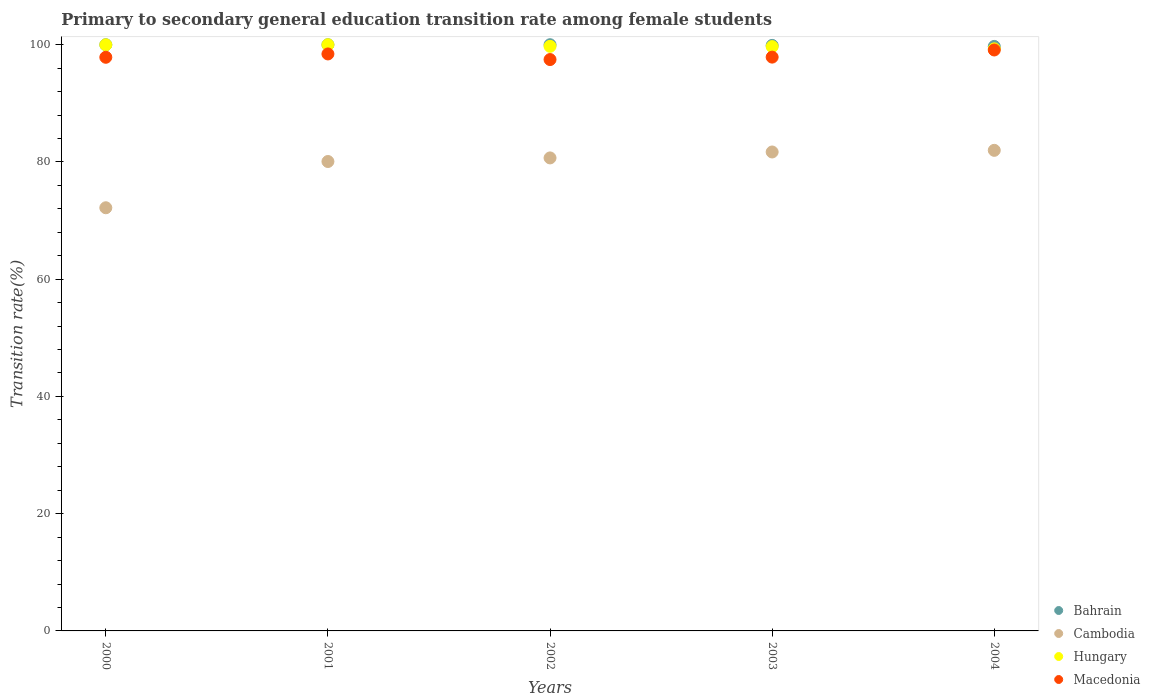What is the transition rate in Macedonia in 2002?
Your answer should be very brief. 97.47. Across all years, what is the maximum transition rate in Cambodia?
Offer a very short reply. 81.98. Across all years, what is the minimum transition rate in Hungary?
Give a very brief answer. 99.3. What is the total transition rate in Macedonia in the graph?
Your answer should be very brief. 490.74. What is the difference between the transition rate in Hungary in 2002 and that in 2003?
Make the answer very short. 0.05. What is the difference between the transition rate in Bahrain in 2003 and the transition rate in Cambodia in 2001?
Offer a terse response. 19.81. What is the average transition rate in Cambodia per year?
Your answer should be very brief. 79.33. In the year 2002, what is the difference between the transition rate in Cambodia and transition rate in Bahrain?
Your response must be concise. -19.31. In how many years, is the transition rate in Hungary greater than 20 %?
Make the answer very short. 5. What is the ratio of the transition rate in Hungary in 2000 to that in 2002?
Your response must be concise. 1. Is the transition rate in Hungary in 2000 less than that in 2003?
Keep it short and to the point. No. Is the difference between the transition rate in Cambodia in 2000 and 2001 greater than the difference between the transition rate in Bahrain in 2000 and 2001?
Provide a short and direct response. No. What is the difference between the highest and the second highest transition rate in Macedonia?
Give a very brief answer. 0.67. What is the difference between the highest and the lowest transition rate in Cambodia?
Provide a short and direct response. 9.8. Is it the case that in every year, the sum of the transition rate in Cambodia and transition rate in Macedonia  is greater than the transition rate in Bahrain?
Offer a terse response. Yes. Does the transition rate in Macedonia monotonically increase over the years?
Keep it short and to the point. No. Is the transition rate in Bahrain strictly greater than the transition rate in Hungary over the years?
Provide a succinct answer. No. Is the transition rate in Hungary strictly less than the transition rate in Macedonia over the years?
Your response must be concise. No. How many dotlines are there?
Ensure brevity in your answer.  4. What is the difference between two consecutive major ticks on the Y-axis?
Offer a terse response. 20. Does the graph contain any zero values?
Ensure brevity in your answer.  No. Does the graph contain grids?
Ensure brevity in your answer.  No. Where does the legend appear in the graph?
Offer a very short reply. Bottom right. What is the title of the graph?
Offer a very short reply. Primary to secondary general education transition rate among female students. What is the label or title of the Y-axis?
Ensure brevity in your answer.  Transition rate(%). What is the Transition rate(%) of Bahrain in 2000?
Make the answer very short. 100. What is the Transition rate(%) in Cambodia in 2000?
Keep it short and to the point. 72.19. What is the Transition rate(%) in Hungary in 2000?
Provide a succinct answer. 99.98. What is the Transition rate(%) of Macedonia in 2000?
Your answer should be very brief. 97.86. What is the Transition rate(%) in Bahrain in 2001?
Provide a short and direct response. 100. What is the Transition rate(%) in Cambodia in 2001?
Ensure brevity in your answer.  80.08. What is the Transition rate(%) in Macedonia in 2001?
Ensure brevity in your answer.  98.43. What is the Transition rate(%) of Bahrain in 2002?
Offer a very short reply. 100. What is the Transition rate(%) in Cambodia in 2002?
Give a very brief answer. 80.69. What is the Transition rate(%) in Hungary in 2002?
Ensure brevity in your answer.  99.73. What is the Transition rate(%) of Macedonia in 2002?
Keep it short and to the point. 97.47. What is the Transition rate(%) in Bahrain in 2003?
Your response must be concise. 99.89. What is the Transition rate(%) of Cambodia in 2003?
Give a very brief answer. 81.7. What is the Transition rate(%) of Hungary in 2003?
Provide a short and direct response. 99.68. What is the Transition rate(%) in Macedonia in 2003?
Your answer should be very brief. 97.88. What is the Transition rate(%) in Bahrain in 2004?
Keep it short and to the point. 99.71. What is the Transition rate(%) in Cambodia in 2004?
Your answer should be compact. 81.98. What is the Transition rate(%) of Hungary in 2004?
Provide a succinct answer. 99.3. What is the Transition rate(%) in Macedonia in 2004?
Ensure brevity in your answer.  99.1. Across all years, what is the maximum Transition rate(%) in Bahrain?
Give a very brief answer. 100. Across all years, what is the maximum Transition rate(%) of Cambodia?
Make the answer very short. 81.98. Across all years, what is the maximum Transition rate(%) of Hungary?
Your answer should be compact. 100. Across all years, what is the maximum Transition rate(%) in Macedonia?
Give a very brief answer. 99.1. Across all years, what is the minimum Transition rate(%) of Bahrain?
Your answer should be compact. 99.71. Across all years, what is the minimum Transition rate(%) of Cambodia?
Provide a short and direct response. 72.19. Across all years, what is the minimum Transition rate(%) in Hungary?
Give a very brief answer. 99.3. Across all years, what is the minimum Transition rate(%) of Macedonia?
Offer a terse response. 97.47. What is the total Transition rate(%) of Bahrain in the graph?
Offer a very short reply. 499.6. What is the total Transition rate(%) in Cambodia in the graph?
Offer a terse response. 396.64. What is the total Transition rate(%) in Hungary in the graph?
Give a very brief answer. 498.69. What is the total Transition rate(%) of Macedonia in the graph?
Your answer should be compact. 490.74. What is the difference between the Transition rate(%) in Bahrain in 2000 and that in 2001?
Your answer should be very brief. 0. What is the difference between the Transition rate(%) in Cambodia in 2000 and that in 2001?
Make the answer very short. -7.89. What is the difference between the Transition rate(%) in Hungary in 2000 and that in 2001?
Offer a terse response. -0.02. What is the difference between the Transition rate(%) in Macedonia in 2000 and that in 2001?
Your answer should be compact. -0.57. What is the difference between the Transition rate(%) in Bahrain in 2000 and that in 2002?
Ensure brevity in your answer.  0. What is the difference between the Transition rate(%) of Cambodia in 2000 and that in 2002?
Give a very brief answer. -8.5. What is the difference between the Transition rate(%) of Hungary in 2000 and that in 2002?
Your answer should be compact. 0.26. What is the difference between the Transition rate(%) in Macedonia in 2000 and that in 2002?
Offer a terse response. 0.39. What is the difference between the Transition rate(%) in Bahrain in 2000 and that in 2003?
Your answer should be compact. 0.11. What is the difference between the Transition rate(%) in Cambodia in 2000 and that in 2003?
Offer a terse response. -9.52. What is the difference between the Transition rate(%) in Hungary in 2000 and that in 2003?
Offer a terse response. 0.31. What is the difference between the Transition rate(%) of Macedonia in 2000 and that in 2003?
Offer a very short reply. -0.03. What is the difference between the Transition rate(%) in Bahrain in 2000 and that in 2004?
Provide a short and direct response. 0.29. What is the difference between the Transition rate(%) of Cambodia in 2000 and that in 2004?
Your answer should be very brief. -9.8. What is the difference between the Transition rate(%) in Hungary in 2000 and that in 2004?
Keep it short and to the point. 0.68. What is the difference between the Transition rate(%) of Macedonia in 2000 and that in 2004?
Offer a terse response. -1.24. What is the difference between the Transition rate(%) in Cambodia in 2001 and that in 2002?
Provide a short and direct response. -0.61. What is the difference between the Transition rate(%) of Hungary in 2001 and that in 2002?
Give a very brief answer. 0.27. What is the difference between the Transition rate(%) of Macedonia in 2001 and that in 2002?
Give a very brief answer. 0.96. What is the difference between the Transition rate(%) in Bahrain in 2001 and that in 2003?
Provide a short and direct response. 0.11. What is the difference between the Transition rate(%) of Cambodia in 2001 and that in 2003?
Keep it short and to the point. -1.63. What is the difference between the Transition rate(%) in Hungary in 2001 and that in 2003?
Your response must be concise. 0.32. What is the difference between the Transition rate(%) of Macedonia in 2001 and that in 2003?
Offer a terse response. 0.54. What is the difference between the Transition rate(%) in Bahrain in 2001 and that in 2004?
Your answer should be very brief. 0.29. What is the difference between the Transition rate(%) in Cambodia in 2001 and that in 2004?
Offer a very short reply. -1.91. What is the difference between the Transition rate(%) of Hungary in 2001 and that in 2004?
Your answer should be compact. 0.7. What is the difference between the Transition rate(%) in Macedonia in 2001 and that in 2004?
Your answer should be compact. -0.67. What is the difference between the Transition rate(%) in Bahrain in 2002 and that in 2003?
Your answer should be compact. 0.11. What is the difference between the Transition rate(%) in Cambodia in 2002 and that in 2003?
Your answer should be compact. -1.01. What is the difference between the Transition rate(%) in Hungary in 2002 and that in 2003?
Your answer should be very brief. 0.05. What is the difference between the Transition rate(%) of Macedonia in 2002 and that in 2003?
Provide a succinct answer. -0.41. What is the difference between the Transition rate(%) in Bahrain in 2002 and that in 2004?
Offer a very short reply. 0.29. What is the difference between the Transition rate(%) of Cambodia in 2002 and that in 2004?
Give a very brief answer. -1.29. What is the difference between the Transition rate(%) in Hungary in 2002 and that in 2004?
Your answer should be very brief. 0.42. What is the difference between the Transition rate(%) in Macedonia in 2002 and that in 2004?
Give a very brief answer. -1.63. What is the difference between the Transition rate(%) in Bahrain in 2003 and that in 2004?
Your answer should be very brief. 0.18. What is the difference between the Transition rate(%) in Cambodia in 2003 and that in 2004?
Your answer should be compact. -0.28. What is the difference between the Transition rate(%) in Hungary in 2003 and that in 2004?
Keep it short and to the point. 0.38. What is the difference between the Transition rate(%) of Macedonia in 2003 and that in 2004?
Your response must be concise. -1.22. What is the difference between the Transition rate(%) in Bahrain in 2000 and the Transition rate(%) in Cambodia in 2001?
Your answer should be compact. 19.92. What is the difference between the Transition rate(%) in Bahrain in 2000 and the Transition rate(%) in Hungary in 2001?
Make the answer very short. 0. What is the difference between the Transition rate(%) in Bahrain in 2000 and the Transition rate(%) in Macedonia in 2001?
Offer a very short reply. 1.57. What is the difference between the Transition rate(%) of Cambodia in 2000 and the Transition rate(%) of Hungary in 2001?
Make the answer very short. -27.81. What is the difference between the Transition rate(%) of Cambodia in 2000 and the Transition rate(%) of Macedonia in 2001?
Offer a very short reply. -26.24. What is the difference between the Transition rate(%) of Hungary in 2000 and the Transition rate(%) of Macedonia in 2001?
Provide a short and direct response. 1.56. What is the difference between the Transition rate(%) of Bahrain in 2000 and the Transition rate(%) of Cambodia in 2002?
Provide a short and direct response. 19.31. What is the difference between the Transition rate(%) of Bahrain in 2000 and the Transition rate(%) of Hungary in 2002?
Make the answer very short. 0.27. What is the difference between the Transition rate(%) in Bahrain in 2000 and the Transition rate(%) in Macedonia in 2002?
Provide a short and direct response. 2.53. What is the difference between the Transition rate(%) in Cambodia in 2000 and the Transition rate(%) in Hungary in 2002?
Give a very brief answer. -27.54. What is the difference between the Transition rate(%) in Cambodia in 2000 and the Transition rate(%) in Macedonia in 2002?
Make the answer very short. -25.28. What is the difference between the Transition rate(%) in Hungary in 2000 and the Transition rate(%) in Macedonia in 2002?
Ensure brevity in your answer.  2.51. What is the difference between the Transition rate(%) of Bahrain in 2000 and the Transition rate(%) of Cambodia in 2003?
Offer a terse response. 18.3. What is the difference between the Transition rate(%) of Bahrain in 2000 and the Transition rate(%) of Hungary in 2003?
Give a very brief answer. 0.32. What is the difference between the Transition rate(%) in Bahrain in 2000 and the Transition rate(%) in Macedonia in 2003?
Ensure brevity in your answer.  2.12. What is the difference between the Transition rate(%) of Cambodia in 2000 and the Transition rate(%) of Hungary in 2003?
Your response must be concise. -27.49. What is the difference between the Transition rate(%) in Cambodia in 2000 and the Transition rate(%) in Macedonia in 2003?
Ensure brevity in your answer.  -25.7. What is the difference between the Transition rate(%) in Hungary in 2000 and the Transition rate(%) in Macedonia in 2003?
Provide a short and direct response. 2.1. What is the difference between the Transition rate(%) of Bahrain in 2000 and the Transition rate(%) of Cambodia in 2004?
Provide a short and direct response. 18.02. What is the difference between the Transition rate(%) in Bahrain in 2000 and the Transition rate(%) in Hungary in 2004?
Your response must be concise. 0.7. What is the difference between the Transition rate(%) of Bahrain in 2000 and the Transition rate(%) of Macedonia in 2004?
Give a very brief answer. 0.9. What is the difference between the Transition rate(%) of Cambodia in 2000 and the Transition rate(%) of Hungary in 2004?
Give a very brief answer. -27.11. What is the difference between the Transition rate(%) in Cambodia in 2000 and the Transition rate(%) in Macedonia in 2004?
Your answer should be compact. -26.92. What is the difference between the Transition rate(%) in Hungary in 2000 and the Transition rate(%) in Macedonia in 2004?
Offer a terse response. 0.88. What is the difference between the Transition rate(%) of Bahrain in 2001 and the Transition rate(%) of Cambodia in 2002?
Ensure brevity in your answer.  19.31. What is the difference between the Transition rate(%) of Bahrain in 2001 and the Transition rate(%) of Hungary in 2002?
Your answer should be very brief. 0.27. What is the difference between the Transition rate(%) in Bahrain in 2001 and the Transition rate(%) in Macedonia in 2002?
Your answer should be very brief. 2.53. What is the difference between the Transition rate(%) of Cambodia in 2001 and the Transition rate(%) of Hungary in 2002?
Make the answer very short. -19.65. What is the difference between the Transition rate(%) in Cambodia in 2001 and the Transition rate(%) in Macedonia in 2002?
Make the answer very short. -17.39. What is the difference between the Transition rate(%) in Hungary in 2001 and the Transition rate(%) in Macedonia in 2002?
Provide a succinct answer. 2.53. What is the difference between the Transition rate(%) in Bahrain in 2001 and the Transition rate(%) in Cambodia in 2003?
Ensure brevity in your answer.  18.3. What is the difference between the Transition rate(%) of Bahrain in 2001 and the Transition rate(%) of Hungary in 2003?
Provide a succinct answer. 0.32. What is the difference between the Transition rate(%) in Bahrain in 2001 and the Transition rate(%) in Macedonia in 2003?
Offer a terse response. 2.12. What is the difference between the Transition rate(%) in Cambodia in 2001 and the Transition rate(%) in Hungary in 2003?
Offer a terse response. -19.6. What is the difference between the Transition rate(%) in Cambodia in 2001 and the Transition rate(%) in Macedonia in 2003?
Your response must be concise. -17.81. What is the difference between the Transition rate(%) of Hungary in 2001 and the Transition rate(%) of Macedonia in 2003?
Your answer should be very brief. 2.12. What is the difference between the Transition rate(%) in Bahrain in 2001 and the Transition rate(%) in Cambodia in 2004?
Provide a short and direct response. 18.02. What is the difference between the Transition rate(%) in Bahrain in 2001 and the Transition rate(%) in Hungary in 2004?
Provide a short and direct response. 0.7. What is the difference between the Transition rate(%) of Bahrain in 2001 and the Transition rate(%) of Macedonia in 2004?
Give a very brief answer. 0.9. What is the difference between the Transition rate(%) in Cambodia in 2001 and the Transition rate(%) in Hungary in 2004?
Your answer should be very brief. -19.22. What is the difference between the Transition rate(%) of Cambodia in 2001 and the Transition rate(%) of Macedonia in 2004?
Provide a short and direct response. -19.02. What is the difference between the Transition rate(%) of Hungary in 2001 and the Transition rate(%) of Macedonia in 2004?
Provide a succinct answer. 0.9. What is the difference between the Transition rate(%) of Bahrain in 2002 and the Transition rate(%) of Cambodia in 2003?
Your answer should be very brief. 18.3. What is the difference between the Transition rate(%) in Bahrain in 2002 and the Transition rate(%) in Hungary in 2003?
Offer a very short reply. 0.32. What is the difference between the Transition rate(%) in Bahrain in 2002 and the Transition rate(%) in Macedonia in 2003?
Give a very brief answer. 2.12. What is the difference between the Transition rate(%) in Cambodia in 2002 and the Transition rate(%) in Hungary in 2003?
Your answer should be compact. -18.99. What is the difference between the Transition rate(%) of Cambodia in 2002 and the Transition rate(%) of Macedonia in 2003?
Your answer should be very brief. -17.19. What is the difference between the Transition rate(%) in Hungary in 2002 and the Transition rate(%) in Macedonia in 2003?
Ensure brevity in your answer.  1.84. What is the difference between the Transition rate(%) of Bahrain in 2002 and the Transition rate(%) of Cambodia in 2004?
Make the answer very short. 18.02. What is the difference between the Transition rate(%) of Bahrain in 2002 and the Transition rate(%) of Hungary in 2004?
Make the answer very short. 0.7. What is the difference between the Transition rate(%) of Bahrain in 2002 and the Transition rate(%) of Macedonia in 2004?
Offer a very short reply. 0.9. What is the difference between the Transition rate(%) of Cambodia in 2002 and the Transition rate(%) of Hungary in 2004?
Your answer should be compact. -18.61. What is the difference between the Transition rate(%) in Cambodia in 2002 and the Transition rate(%) in Macedonia in 2004?
Offer a terse response. -18.41. What is the difference between the Transition rate(%) in Hungary in 2002 and the Transition rate(%) in Macedonia in 2004?
Offer a very short reply. 0.62. What is the difference between the Transition rate(%) of Bahrain in 2003 and the Transition rate(%) of Cambodia in 2004?
Your response must be concise. 17.9. What is the difference between the Transition rate(%) of Bahrain in 2003 and the Transition rate(%) of Hungary in 2004?
Provide a short and direct response. 0.58. What is the difference between the Transition rate(%) in Bahrain in 2003 and the Transition rate(%) in Macedonia in 2004?
Provide a short and direct response. 0.78. What is the difference between the Transition rate(%) of Cambodia in 2003 and the Transition rate(%) of Hungary in 2004?
Keep it short and to the point. -17.6. What is the difference between the Transition rate(%) of Cambodia in 2003 and the Transition rate(%) of Macedonia in 2004?
Your response must be concise. -17.4. What is the difference between the Transition rate(%) of Hungary in 2003 and the Transition rate(%) of Macedonia in 2004?
Offer a very short reply. 0.57. What is the average Transition rate(%) in Bahrain per year?
Keep it short and to the point. 99.92. What is the average Transition rate(%) of Cambodia per year?
Your answer should be compact. 79.33. What is the average Transition rate(%) in Hungary per year?
Provide a succinct answer. 99.74. What is the average Transition rate(%) in Macedonia per year?
Your response must be concise. 98.15. In the year 2000, what is the difference between the Transition rate(%) of Bahrain and Transition rate(%) of Cambodia?
Ensure brevity in your answer.  27.81. In the year 2000, what is the difference between the Transition rate(%) in Bahrain and Transition rate(%) in Hungary?
Your answer should be very brief. 0.02. In the year 2000, what is the difference between the Transition rate(%) of Bahrain and Transition rate(%) of Macedonia?
Offer a terse response. 2.14. In the year 2000, what is the difference between the Transition rate(%) in Cambodia and Transition rate(%) in Hungary?
Your response must be concise. -27.8. In the year 2000, what is the difference between the Transition rate(%) of Cambodia and Transition rate(%) of Macedonia?
Your answer should be very brief. -25.67. In the year 2000, what is the difference between the Transition rate(%) in Hungary and Transition rate(%) in Macedonia?
Your answer should be very brief. 2.13. In the year 2001, what is the difference between the Transition rate(%) in Bahrain and Transition rate(%) in Cambodia?
Give a very brief answer. 19.92. In the year 2001, what is the difference between the Transition rate(%) of Bahrain and Transition rate(%) of Hungary?
Provide a short and direct response. 0. In the year 2001, what is the difference between the Transition rate(%) of Bahrain and Transition rate(%) of Macedonia?
Offer a terse response. 1.57. In the year 2001, what is the difference between the Transition rate(%) of Cambodia and Transition rate(%) of Hungary?
Ensure brevity in your answer.  -19.92. In the year 2001, what is the difference between the Transition rate(%) of Cambodia and Transition rate(%) of Macedonia?
Give a very brief answer. -18.35. In the year 2001, what is the difference between the Transition rate(%) in Hungary and Transition rate(%) in Macedonia?
Ensure brevity in your answer.  1.57. In the year 2002, what is the difference between the Transition rate(%) in Bahrain and Transition rate(%) in Cambodia?
Your response must be concise. 19.31. In the year 2002, what is the difference between the Transition rate(%) in Bahrain and Transition rate(%) in Hungary?
Offer a terse response. 0.27. In the year 2002, what is the difference between the Transition rate(%) of Bahrain and Transition rate(%) of Macedonia?
Keep it short and to the point. 2.53. In the year 2002, what is the difference between the Transition rate(%) in Cambodia and Transition rate(%) in Hungary?
Make the answer very short. -19.03. In the year 2002, what is the difference between the Transition rate(%) of Cambodia and Transition rate(%) of Macedonia?
Make the answer very short. -16.78. In the year 2002, what is the difference between the Transition rate(%) in Hungary and Transition rate(%) in Macedonia?
Provide a succinct answer. 2.26. In the year 2003, what is the difference between the Transition rate(%) in Bahrain and Transition rate(%) in Cambodia?
Keep it short and to the point. 18.18. In the year 2003, what is the difference between the Transition rate(%) in Bahrain and Transition rate(%) in Hungary?
Keep it short and to the point. 0.21. In the year 2003, what is the difference between the Transition rate(%) in Bahrain and Transition rate(%) in Macedonia?
Provide a succinct answer. 2. In the year 2003, what is the difference between the Transition rate(%) of Cambodia and Transition rate(%) of Hungary?
Offer a very short reply. -17.97. In the year 2003, what is the difference between the Transition rate(%) of Cambodia and Transition rate(%) of Macedonia?
Your response must be concise. -16.18. In the year 2003, what is the difference between the Transition rate(%) of Hungary and Transition rate(%) of Macedonia?
Give a very brief answer. 1.79. In the year 2004, what is the difference between the Transition rate(%) in Bahrain and Transition rate(%) in Cambodia?
Provide a short and direct response. 17.73. In the year 2004, what is the difference between the Transition rate(%) in Bahrain and Transition rate(%) in Hungary?
Offer a very short reply. 0.41. In the year 2004, what is the difference between the Transition rate(%) in Bahrain and Transition rate(%) in Macedonia?
Offer a very short reply. 0.61. In the year 2004, what is the difference between the Transition rate(%) of Cambodia and Transition rate(%) of Hungary?
Make the answer very short. -17.32. In the year 2004, what is the difference between the Transition rate(%) of Cambodia and Transition rate(%) of Macedonia?
Offer a terse response. -17.12. In the year 2004, what is the difference between the Transition rate(%) in Hungary and Transition rate(%) in Macedonia?
Provide a succinct answer. 0.2. What is the ratio of the Transition rate(%) in Bahrain in 2000 to that in 2001?
Give a very brief answer. 1. What is the ratio of the Transition rate(%) of Cambodia in 2000 to that in 2001?
Your answer should be very brief. 0.9. What is the ratio of the Transition rate(%) of Macedonia in 2000 to that in 2001?
Offer a terse response. 0.99. What is the ratio of the Transition rate(%) of Cambodia in 2000 to that in 2002?
Make the answer very short. 0.89. What is the ratio of the Transition rate(%) in Hungary in 2000 to that in 2002?
Offer a very short reply. 1. What is the ratio of the Transition rate(%) of Macedonia in 2000 to that in 2002?
Make the answer very short. 1. What is the ratio of the Transition rate(%) of Bahrain in 2000 to that in 2003?
Keep it short and to the point. 1. What is the ratio of the Transition rate(%) of Cambodia in 2000 to that in 2003?
Offer a very short reply. 0.88. What is the ratio of the Transition rate(%) in Hungary in 2000 to that in 2003?
Keep it short and to the point. 1. What is the ratio of the Transition rate(%) of Cambodia in 2000 to that in 2004?
Offer a very short reply. 0.88. What is the ratio of the Transition rate(%) of Macedonia in 2000 to that in 2004?
Provide a succinct answer. 0.99. What is the ratio of the Transition rate(%) in Cambodia in 2001 to that in 2002?
Ensure brevity in your answer.  0.99. What is the ratio of the Transition rate(%) of Macedonia in 2001 to that in 2002?
Your answer should be very brief. 1.01. What is the ratio of the Transition rate(%) of Cambodia in 2001 to that in 2003?
Keep it short and to the point. 0.98. What is the ratio of the Transition rate(%) in Hungary in 2001 to that in 2003?
Offer a very short reply. 1. What is the ratio of the Transition rate(%) of Cambodia in 2001 to that in 2004?
Offer a terse response. 0.98. What is the ratio of the Transition rate(%) in Macedonia in 2001 to that in 2004?
Your response must be concise. 0.99. What is the ratio of the Transition rate(%) of Bahrain in 2002 to that in 2003?
Offer a very short reply. 1. What is the ratio of the Transition rate(%) in Cambodia in 2002 to that in 2003?
Make the answer very short. 0.99. What is the ratio of the Transition rate(%) of Hungary in 2002 to that in 2003?
Your answer should be compact. 1. What is the ratio of the Transition rate(%) of Cambodia in 2002 to that in 2004?
Ensure brevity in your answer.  0.98. What is the ratio of the Transition rate(%) in Hungary in 2002 to that in 2004?
Your response must be concise. 1. What is the ratio of the Transition rate(%) in Macedonia in 2002 to that in 2004?
Make the answer very short. 0.98. What is the ratio of the Transition rate(%) of Hungary in 2003 to that in 2004?
Your response must be concise. 1. What is the ratio of the Transition rate(%) in Macedonia in 2003 to that in 2004?
Keep it short and to the point. 0.99. What is the difference between the highest and the second highest Transition rate(%) of Bahrain?
Your answer should be very brief. 0. What is the difference between the highest and the second highest Transition rate(%) of Cambodia?
Offer a very short reply. 0.28. What is the difference between the highest and the second highest Transition rate(%) of Hungary?
Give a very brief answer. 0.02. What is the difference between the highest and the second highest Transition rate(%) in Macedonia?
Your response must be concise. 0.67. What is the difference between the highest and the lowest Transition rate(%) in Bahrain?
Your answer should be compact. 0.29. What is the difference between the highest and the lowest Transition rate(%) in Cambodia?
Ensure brevity in your answer.  9.8. What is the difference between the highest and the lowest Transition rate(%) in Hungary?
Keep it short and to the point. 0.7. What is the difference between the highest and the lowest Transition rate(%) of Macedonia?
Your response must be concise. 1.63. 